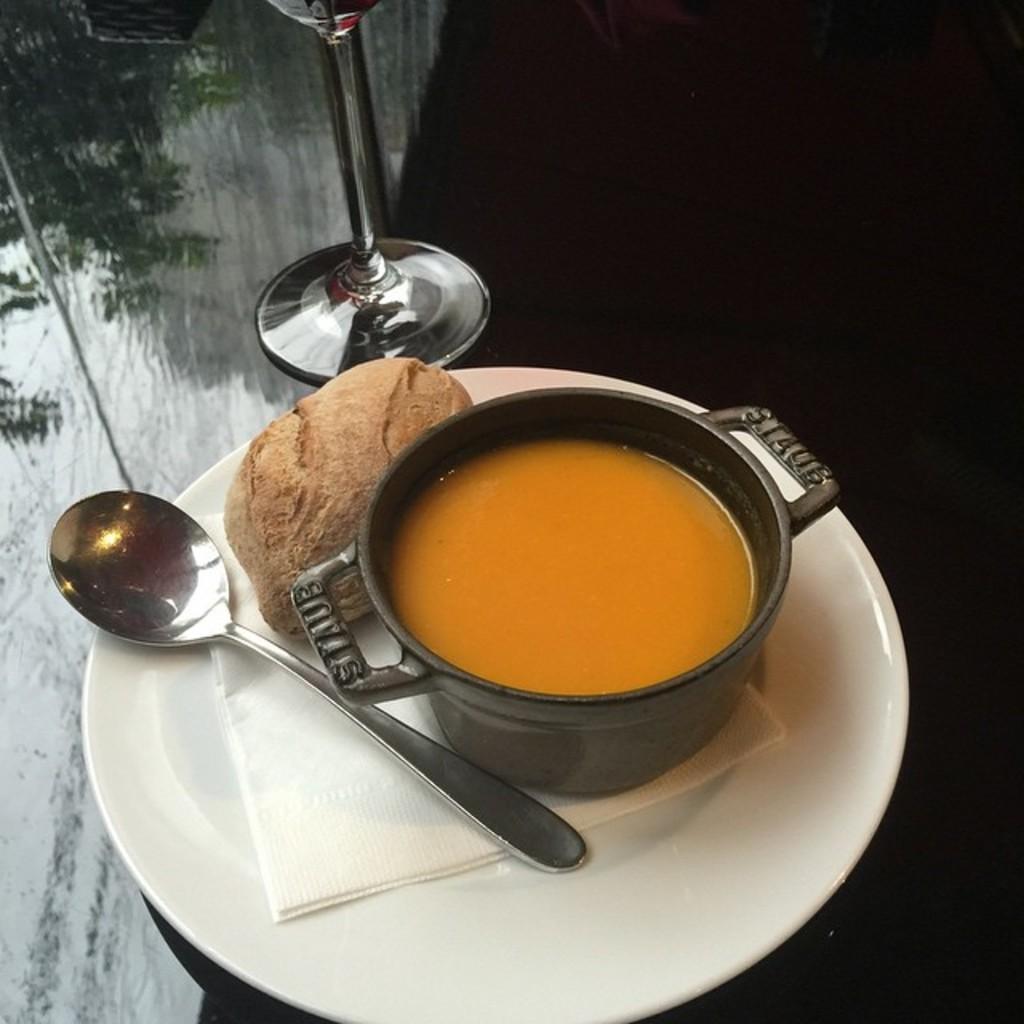In one or two sentences, can you explain what this image depicts? In this image there is a plate on which there is a plate on which there is cup of juice and there is a spoon beside it. In the background there is a glass. Beside the cup there is some food item. 